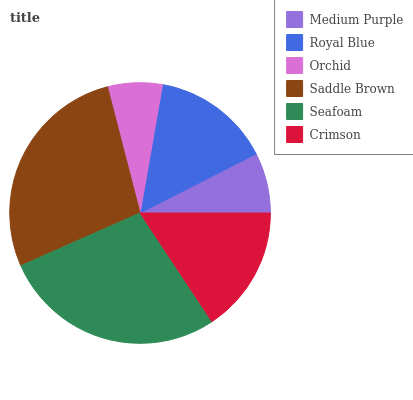Is Orchid the minimum?
Answer yes or no. Yes. Is Seafoam the maximum?
Answer yes or no. Yes. Is Royal Blue the minimum?
Answer yes or no. No. Is Royal Blue the maximum?
Answer yes or no. No. Is Royal Blue greater than Medium Purple?
Answer yes or no. Yes. Is Medium Purple less than Royal Blue?
Answer yes or no. Yes. Is Medium Purple greater than Royal Blue?
Answer yes or no. No. Is Royal Blue less than Medium Purple?
Answer yes or no. No. Is Crimson the high median?
Answer yes or no. Yes. Is Royal Blue the low median?
Answer yes or no. Yes. Is Seafoam the high median?
Answer yes or no. No. Is Seafoam the low median?
Answer yes or no. No. 